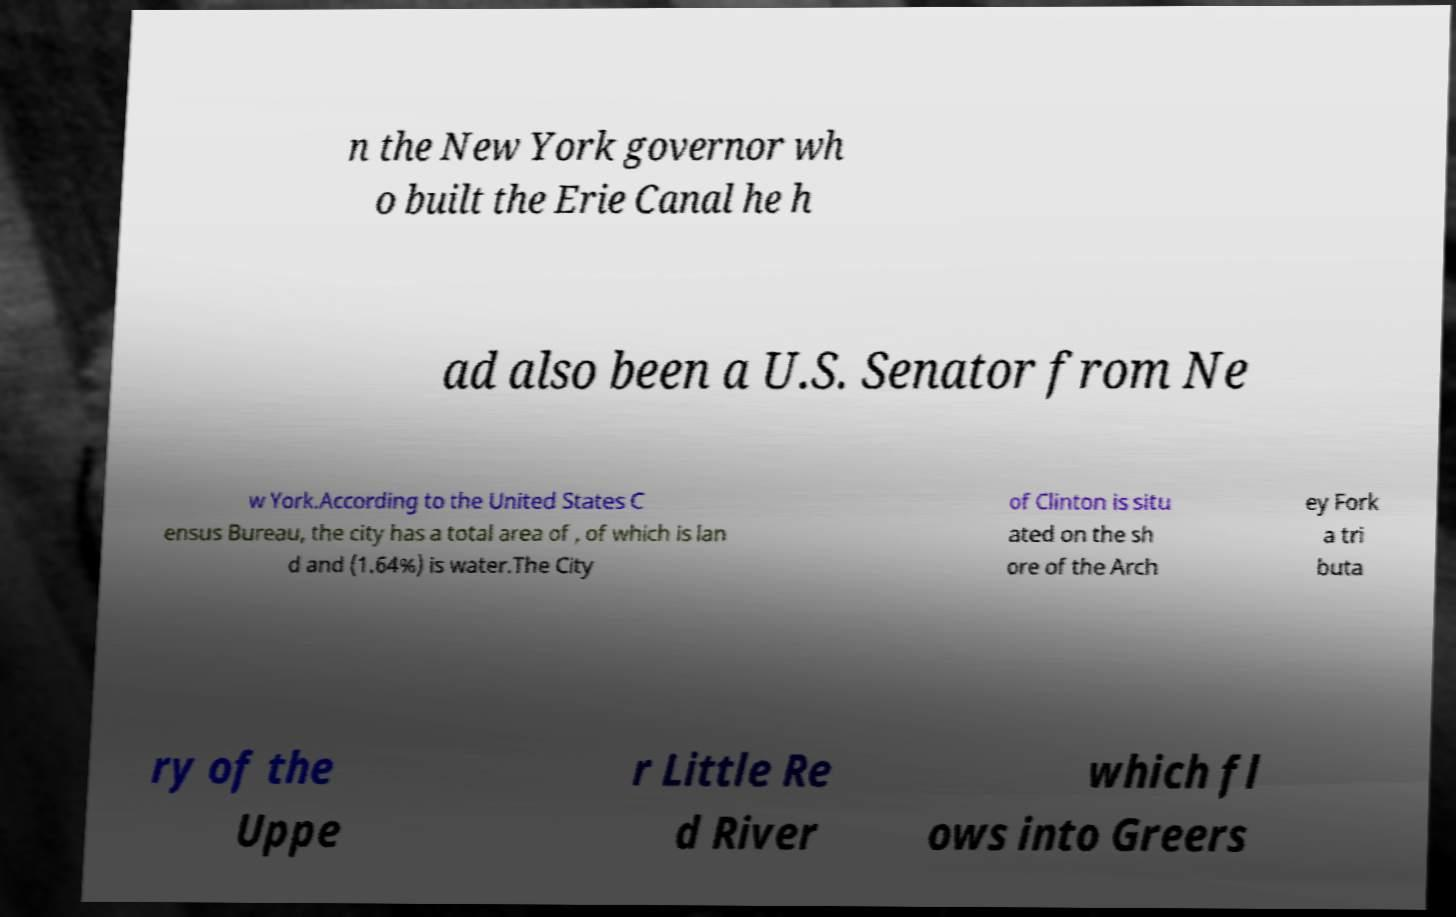Could you extract and type out the text from this image? n the New York governor wh o built the Erie Canal he h ad also been a U.S. Senator from Ne w York.According to the United States C ensus Bureau, the city has a total area of , of which is lan d and (1.64%) is water.The City of Clinton is situ ated on the sh ore of the Arch ey Fork a tri buta ry of the Uppe r Little Re d River which fl ows into Greers 